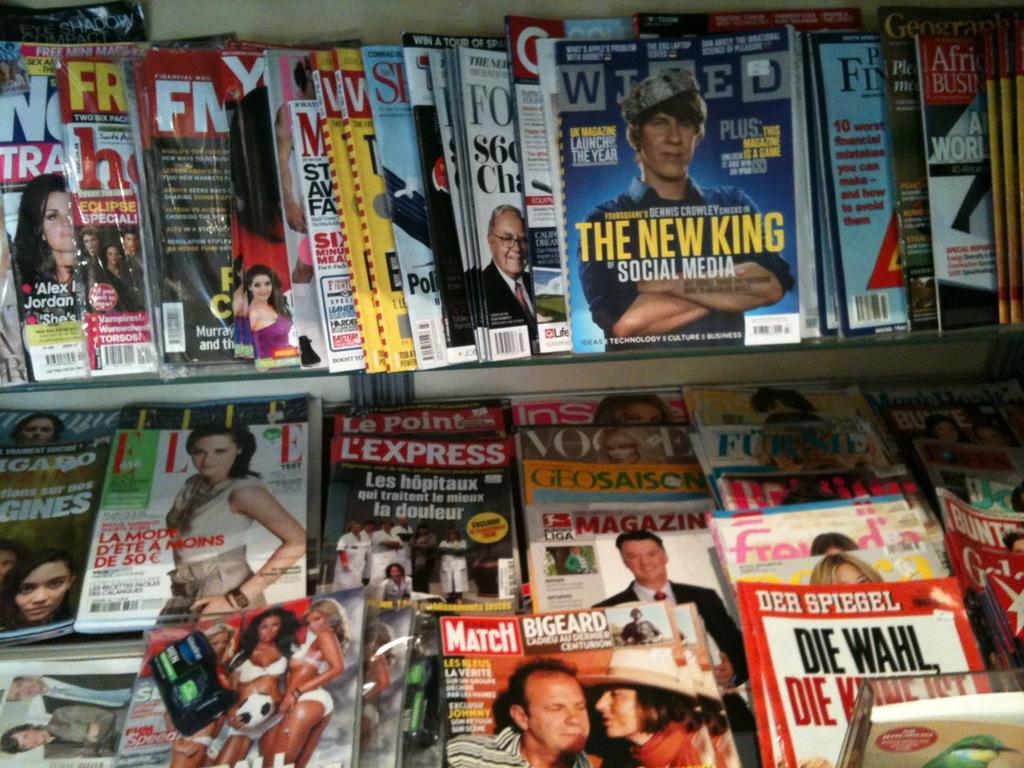Who is the new king of social media?
Give a very brief answer. Dennis crowley. What is a king of social media?
Give a very brief answer. Dennis crowley. 